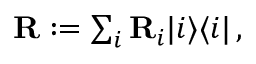Convert formula to latex. <formula><loc_0><loc_0><loc_500><loc_500>\begin{array} { r } { { R } \colon = \sum _ { i } { R } _ { i } | i \rangle \langle i | \, , } \end{array}</formula> 